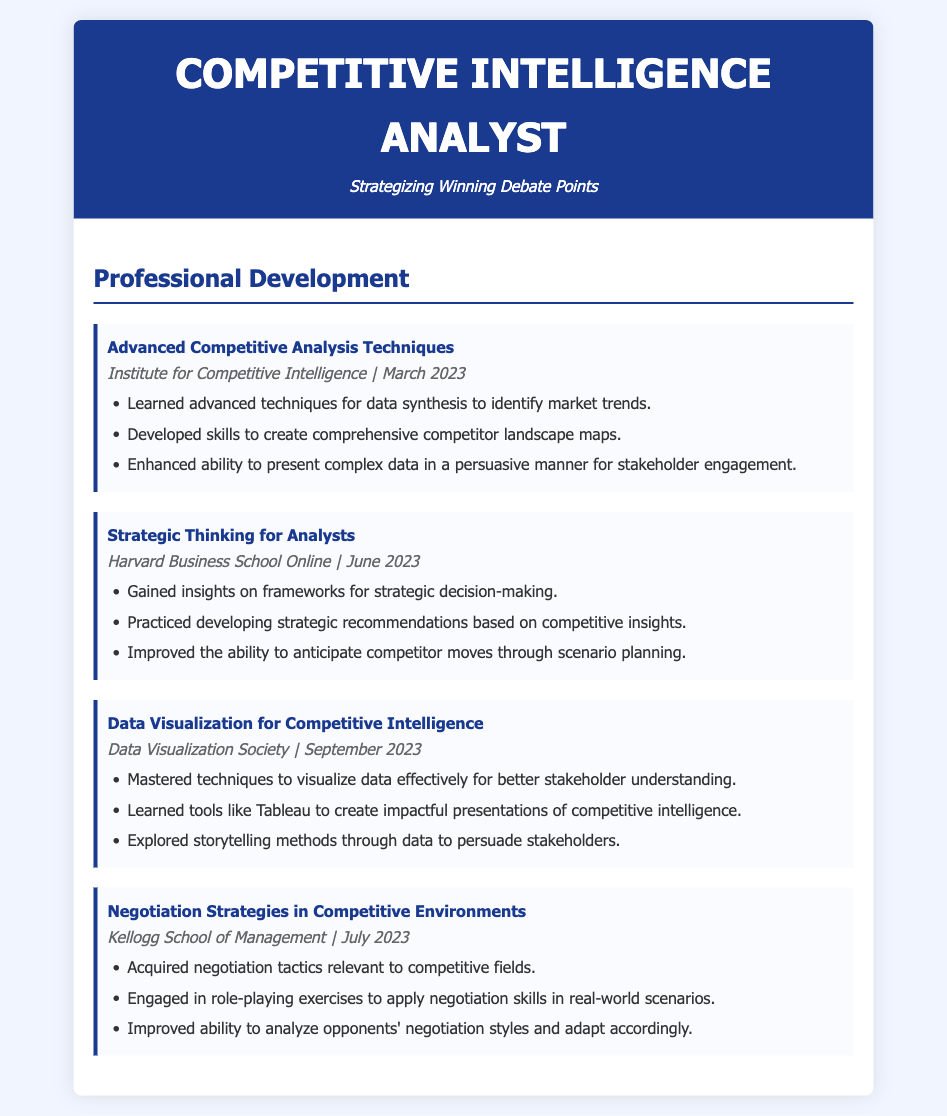What is the title of the first workshop attended? The title of the first workshop is mentioned in the section on Professional Development.
Answer: Advanced Competitive Analysis Techniques Who conducted the second workshop? The name of the institution that conducted the second workshop is provided in the workshop details.
Answer: Harvard Business School Online In what month was the Data Visualization workshop attended? The month of attendance for the Data Visualization workshop is stated in the workshop details.
Answer: September How many key takeaways are listed for the Negotiation Strategies workshop? The number of key takeaways can be counted from the listed items under the Negotiation Strategies workshop.
Answer: Three What skill did the Advanced Competitive Analysis Techniques workshop enhance? The specific skill enhanced by the workshop is indicated within the key takeaways section.
Answer: Presenting complex data What was the focus of the Strategic Thinking for Analysts workshop? The focus of the workshop can be inferred from the key insights gained during the session.
Answer: Strategic decision-making Which tool was mentioned in the Data Visualization workshop? The tool learned during the Data Visualization workshop is explicitly stated in the key takeaways.
Answer: Tableau 